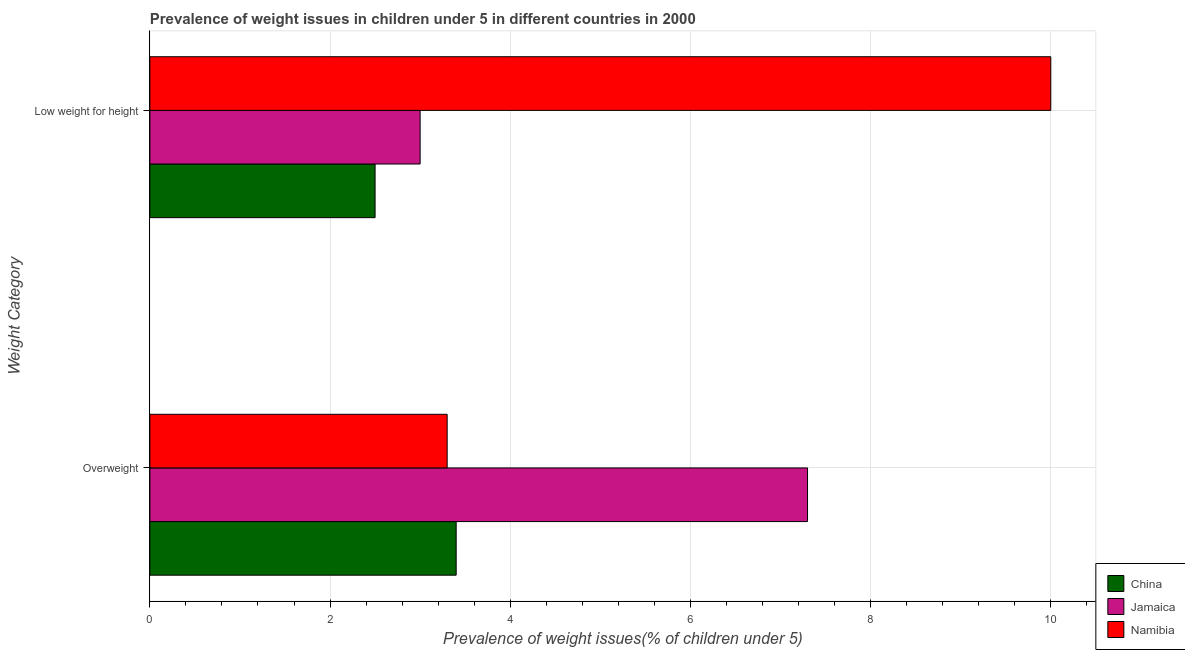How many different coloured bars are there?
Give a very brief answer. 3. Are the number of bars on each tick of the Y-axis equal?
Your response must be concise. Yes. What is the label of the 2nd group of bars from the top?
Give a very brief answer. Overweight. Across all countries, what is the maximum percentage of underweight children?
Keep it short and to the point. 10. Across all countries, what is the minimum percentage of overweight children?
Your response must be concise. 3.3. In which country was the percentage of underweight children maximum?
Provide a succinct answer. Namibia. In which country was the percentage of overweight children minimum?
Your answer should be very brief. Namibia. What is the total percentage of overweight children in the graph?
Your answer should be compact. 14. What is the difference between the percentage of overweight children in Namibia and that in Jamaica?
Keep it short and to the point. -4. What is the difference between the percentage of overweight children in China and the percentage of underweight children in Jamaica?
Offer a very short reply. 0.4. What is the average percentage of underweight children per country?
Make the answer very short. 5.17. What is the difference between the percentage of underweight children and percentage of overweight children in Jamaica?
Give a very brief answer. -4.3. In how many countries, is the percentage of underweight children greater than 5.6 %?
Offer a terse response. 1. What is the ratio of the percentage of underweight children in Jamaica to that in Namibia?
Provide a short and direct response. 0.3. Is the percentage of underweight children in Namibia less than that in Jamaica?
Make the answer very short. No. In how many countries, is the percentage of underweight children greater than the average percentage of underweight children taken over all countries?
Offer a very short reply. 1. What does the 1st bar from the top in Overweight represents?
Your answer should be very brief. Namibia. What does the 3rd bar from the bottom in Low weight for height represents?
Keep it short and to the point. Namibia. Are all the bars in the graph horizontal?
Your answer should be very brief. Yes. How many countries are there in the graph?
Provide a short and direct response. 3. What is the difference between two consecutive major ticks on the X-axis?
Offer a terse response. 2. Are the values on the major ticks of X-axis written in scientific E-notation?
Keep it short and to the point. No. Does the graph contain any zero values?
Your answer should be compact. No. How many legend labels are there?
Ensure brevity in your answer.  3. How are the legend labels stacked?
Give a very brief answer. Vertical. What is the title of the graph?
Offer a very short reply. Prevalence of weight issues in children under 5 in different countries in 2000. What is the label or title of the X-axis?
Your answer should be compact. Prevalence of weight issues(% of children under 5). What is the label or title of the Y-axis?
Ensure brevity in your answer.  Weight Category. What is the Prevalence of weight issues(% of children under 5) of China in Overweight?
Keep it short and to the point. 3.4. What is the Prevalence of weight issues(% of children under 5) of Jamaica in Overweight?
Give a very brief answer. 7.3. What is the Prevalence of weight issues(% of children under 5) in Namibia in Overweight?
Provide a short and direct response. 3.3. Across all Weight Category, what is the maximum Prevalence of weight issues(% of children under 5) of China?
Offer a terse response. 3.4. Across all Weight Category, what is the maximum Prevalence of weight issues(% of children under 5) of Jamaica?
Your answer should be compact. 7.3. Across all Weight Category, what is the minimum Prevalence of weight issues(% of children under 5) of Namibia?
Keep it short and to the point. 3.3. What is the total Prevalence of weight issues(% of children under 5) in China in the graph?
Keep it short and to the point. 5.9. What is the total Prevalence of weight issues(% of children under 5) in Namibia in the graph?
Offer a very short reply. 13.3. What is the difference between the Prevalence of weight issues(% of children under 5) in Namibia in Overweight and that in Low weight for height?
Offer a terse response. -6.7. What is the average Prevalence of weight issues(% of children under 5) in China per Weight Category?
Provide a succinct answer. 2.95. What is the average Prevalence of weight issues(% of children under 5) in Jamaica per Weight Category?
Your response must be concise. 5.15. What is the average Prevalence of weight issues(% of children under 5) in Namibia per Weight Category?
Your answer should be compact. 6.65. What is the difference between the Prevalence of weight issues(% of children under 5) in Jamaica and Prevalence of weight issues(% of children under 5) in Namibia in Overweight?
Your answer should be compact. 4. What is the difference between the Prevalence of weight issues(% of children under 5) in China and Prevalence of weight issues(% of children under 5) in Jamaica in Low weight for height?
Offer a very short reply. -0.5. What is the ratio of the Prevalence of weight issues(% of children under 5) of China in Overweight to that in Low weight for height?
Provide a succinct answer. 1.36. What is the ratio of the Prevalence of weight issues(% of children under 5) in Jamaica in Overweight to that in Low weight for height?
Provide a succinct answer. 2.43. What is the ratio of the Prevalence of weight issues(% of children under 5) in Namibia in Overweight to that in Low weight for height?
Offer a terse response. 0.33. What is the difference between the highest and the lowest Prevalence of weight issues(% of children under 5) of China?
Offer a terse response. 0.9. What is the difference between the highest and the lowest Prevalence of weight issues(% of children under 5) of Namibia?
Offer a very short reply. 6.7. 